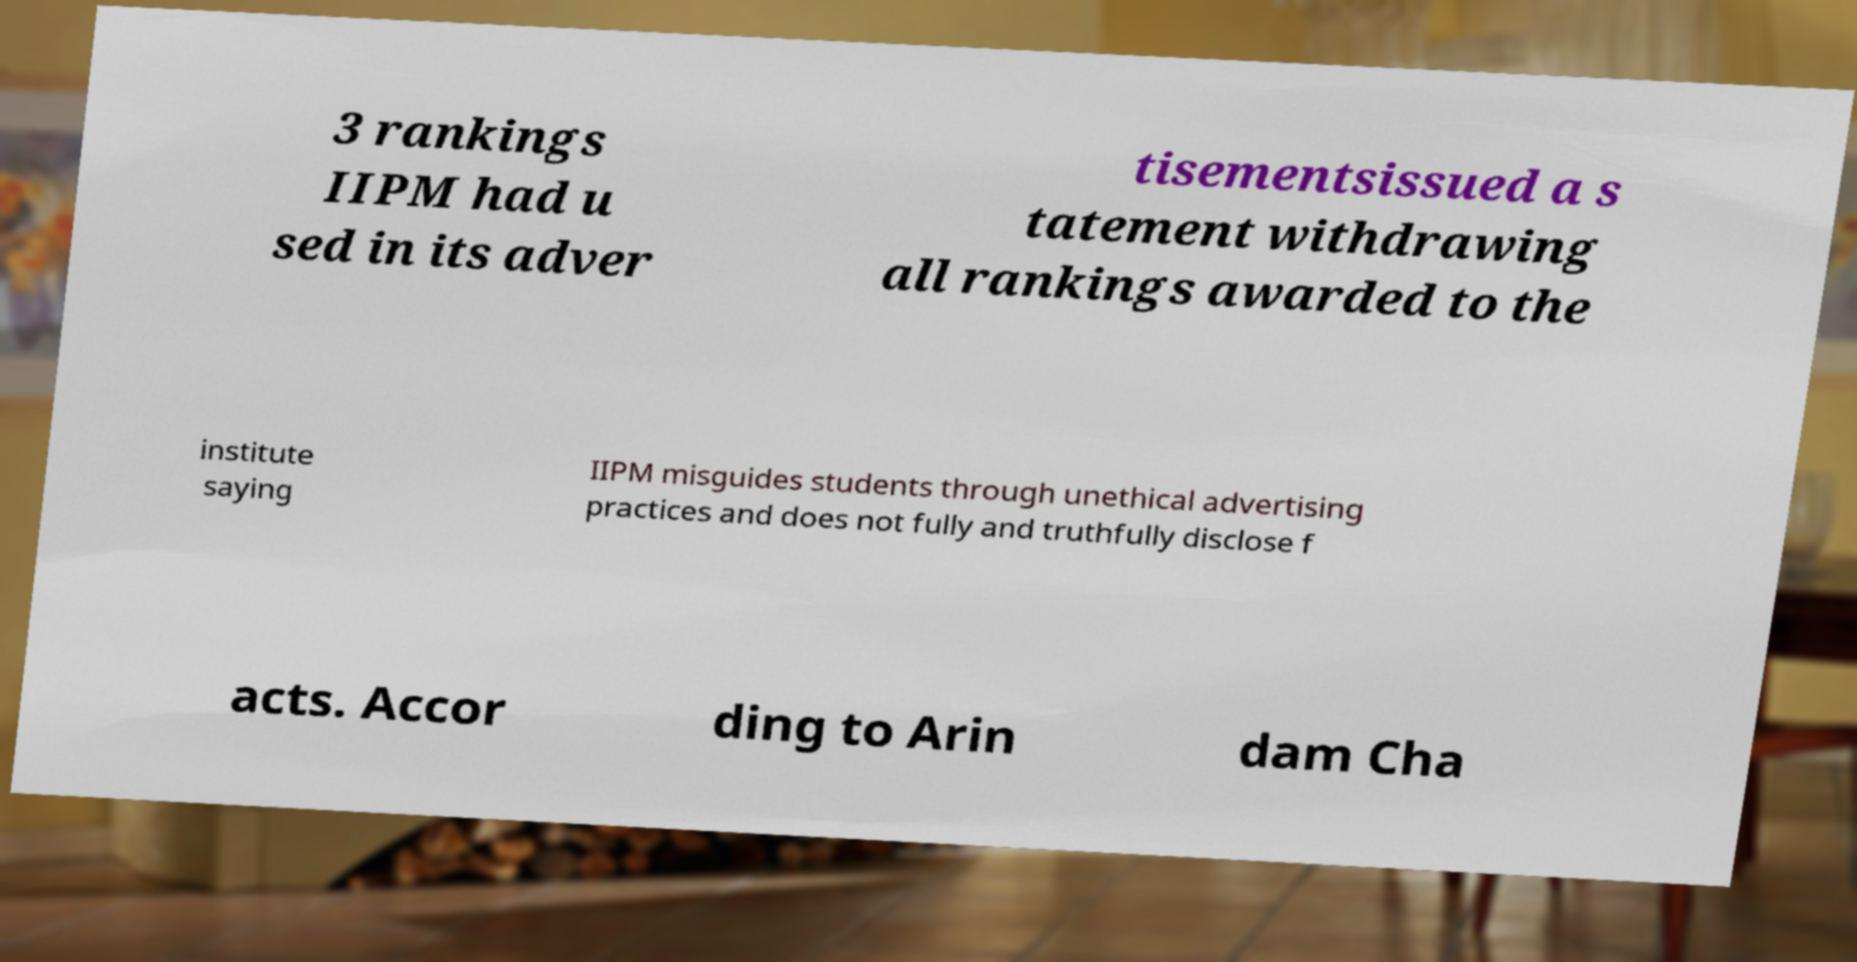I need the written content from this picture converted into text. Can you do that? 3 rankings IIPM had u sed in its adver tisementsissued a s tatement withdrawing all rankings awarded to the institute saying IIPM misguides students through unethical advertising practices and does not fully and truthfully disclose f acts. Accor ding to Arin dam Cha 